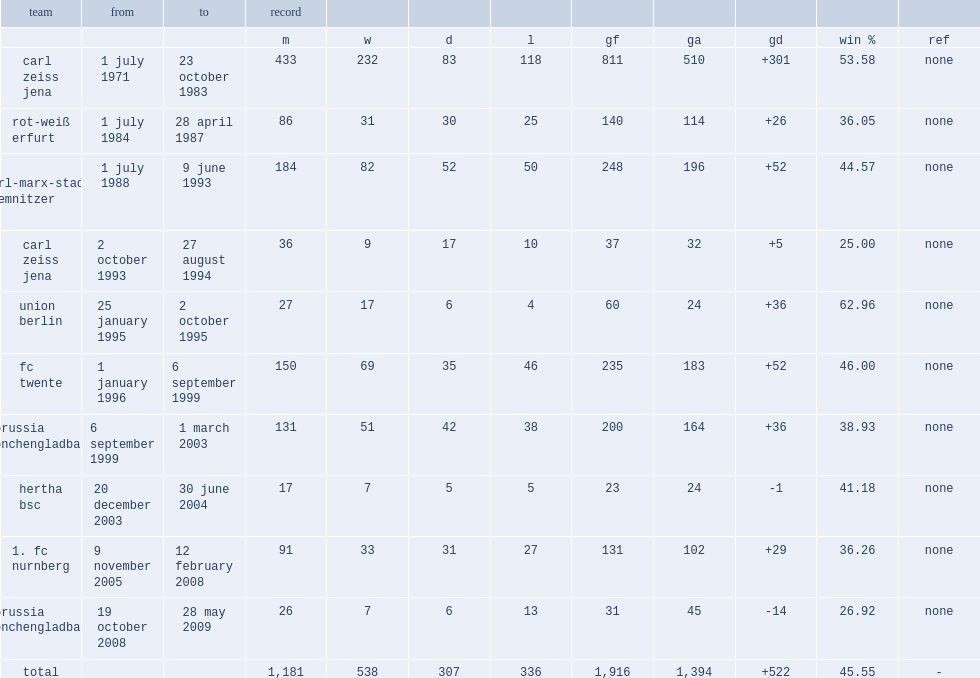Would you be able to parse every entry in this table? {'header': ['team', 'from', 'to', 'record', '', '', '', '', '', '', '', ''], 'rows': [['', '', '', 'm', 'w', 'd', 'l', 'gf', 'ga', 'gd', 'win %', 'ref'], ['carl zeiss jena', '1 july 1971', '23 october 1983', '433', '232', '83', '118', '811', '510', '+301', '53.58', 'none'], ['rot-weiß erfurt', '1 july 1984', '28 april 1987', '86', '31', '30', '25', '140', '114', '+26', '36.05', 'none'], ['fc karl-marx-stadt/ chemnitzer fc', '1 july 1988', '9 june 1993', '184', '82', '52', '50', '248', '196', '+52', '44.57', 'none'], ['carl zeiss jena', '2 october 1993', '27 august 1994', '36', '9', '17', '10', '37', '32', '+5', '25.00', 'none'], ['union berlin', '25 january 1995', '2 october 1995', '27', '17', '6', '4', '60', '24', '+36', '62.96', 'none'], ['fc twente', '1 january 1996', '6 september 1999', '150', '69', '35', '46', '235', '183', '+52', '46.00', 'none'], ['borussia monchengladbach', '6 september 1999', '1 march 2003', '131', '51', '42', '38', '200', '164', '+36', '38.93', 'none'], ['hertha bsc', '20 december 2003', '30 june 2004', '17', '7', '5', '5', '23', '24', '-1', '41.18', 'none'], ['1. fc nurnberg', '9 november 2005', '12 february 2008', '91', '33', '31', '27', '131', '102', '+29', '36.26', 'none'], ['borussia monchengladbach', '19 october 2008', '28 may 2009', '26', '7', '6', '13', '31', '45', '-14', '26.92', 'none'], ['total', '', '', '1,181', '538', '307', '336', '1,916', '1,394', '+522', '45.55', '-']]} When did meyer become the manager of hertha bsc. 20 december 2003. 